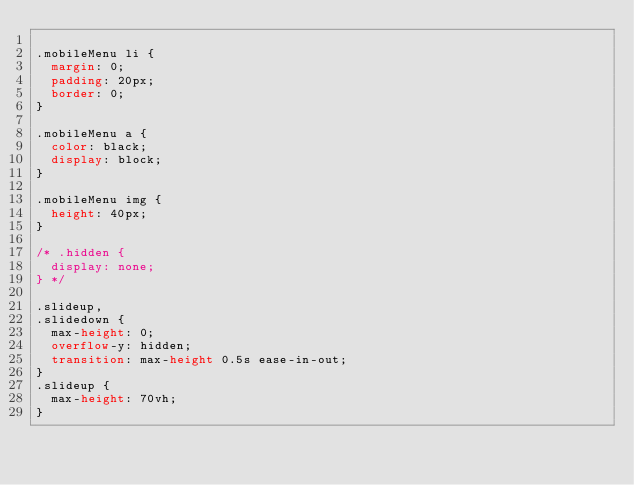Convert code to text. <code><loc_0><loc_0><loc_500><loc_500><_CSS_>
.mobileMenu li {
  margin: 0;
  padding: 20px;
  border: 0;
}

.mobileMenu a {
  color: black;
  display: block;
}

.mobileMenu img {
  height: 40px;
}

/* .hidden {
  display: none;
} */

.slideup,
.slidedown {
  max-height: 0;
  overflow-y: hidden;
  transition: max-height 0.5s ease-in-out;
}
.slideup {
  max-height: 70vh;
}
</code> 